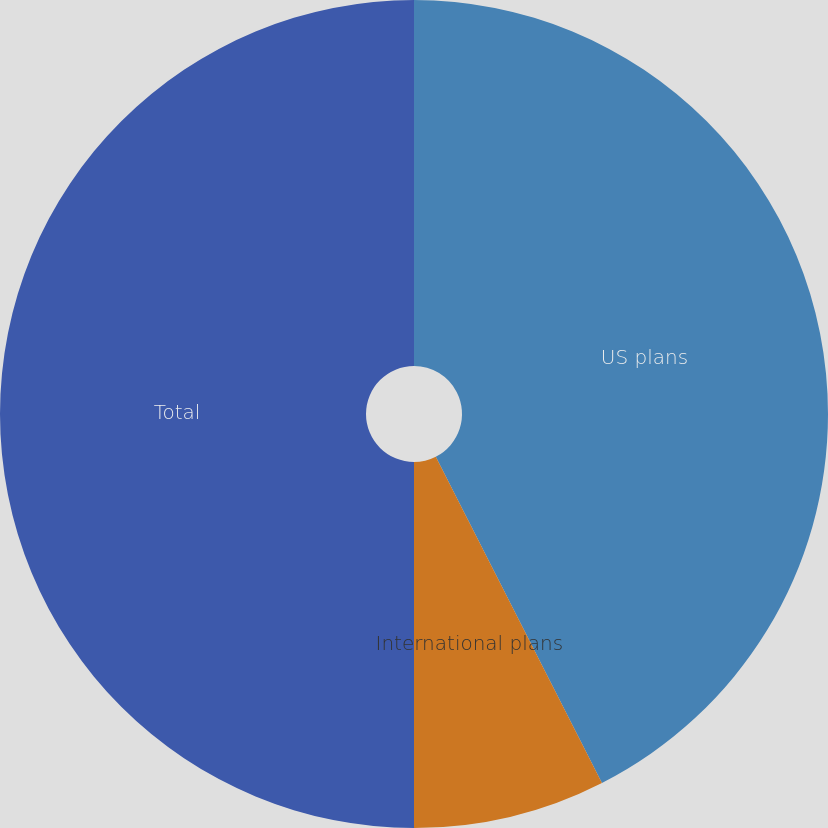Convert chart. <chart><loc_0><loc_0><loc_500><loc_500><pie_chart><fcel>US plans<fcel>International plans<fcel>Total<nl><fcel>42.5%<fcel>7.5%<fcel>50.0%<nl></chart> 